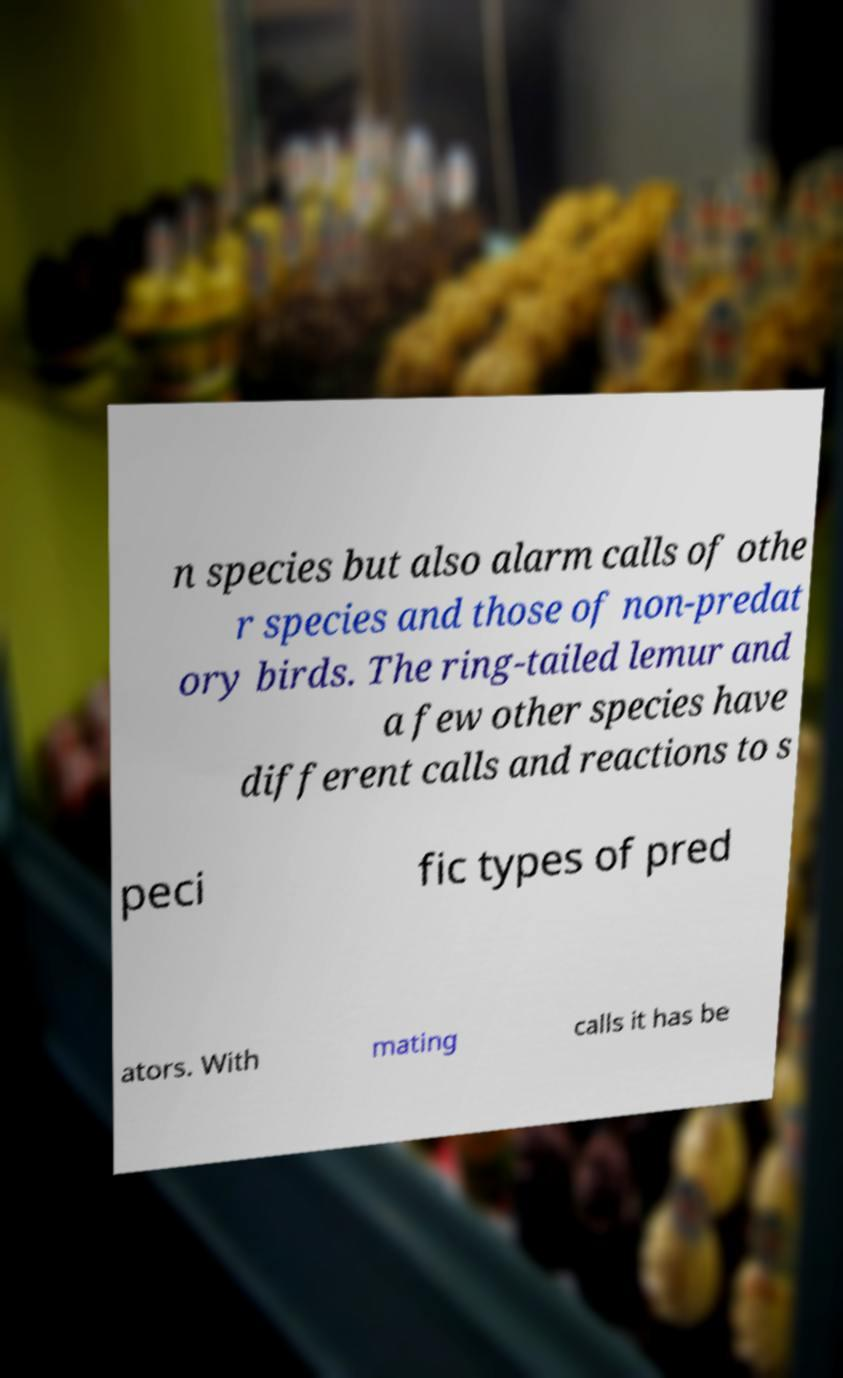For documentation purposes, I need the text within this image transcribed. Could you provide that? n species but also alarm calls of othe r species and those of non-predat ory birds. The ring-tailed lemur and a few other species have different calls and reactions to s peci fic types of pred ators. With mating calls it has be 